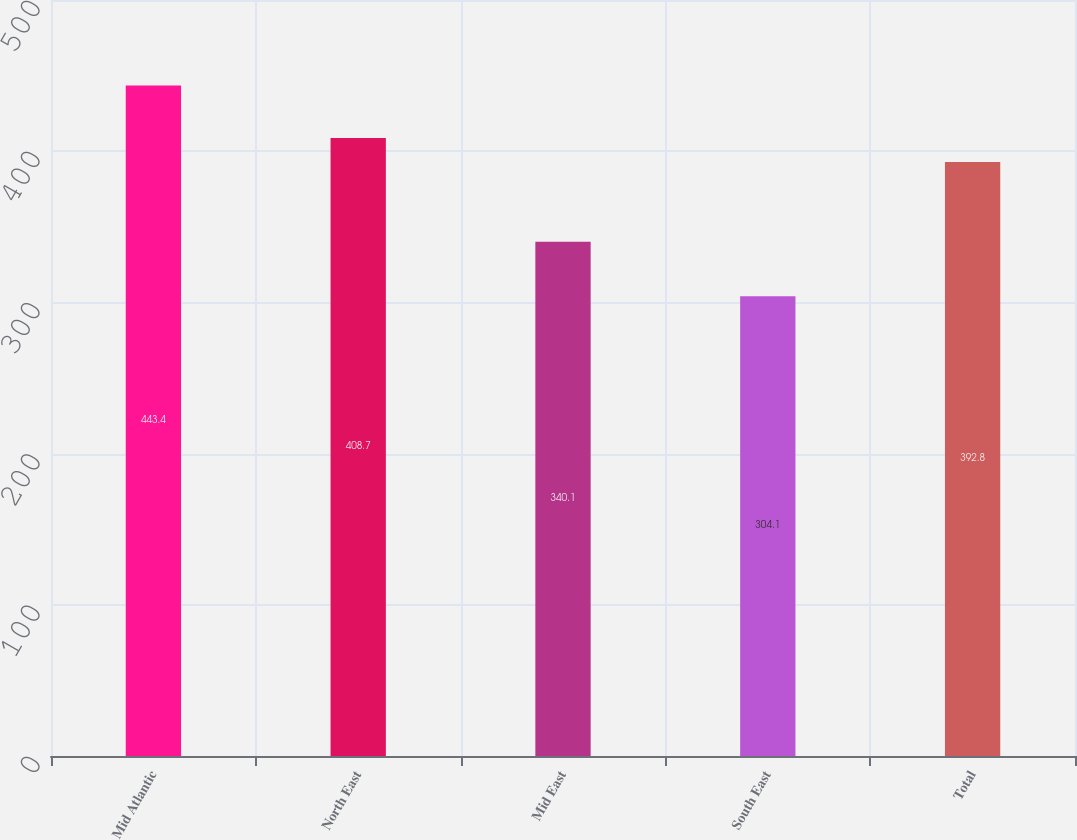Convert chart. <chart><loc_0><loc_0><loc_500><loc_500><bar_chart><fcel>Mid Atlantic<fcel>North East<fcel>Mid East<fcel>South East<fcel>Total<nl><fcel>443.4<fcel>408.7<fcel>340.1<fcel>304.1<fcel>392.8<nl></chart> 